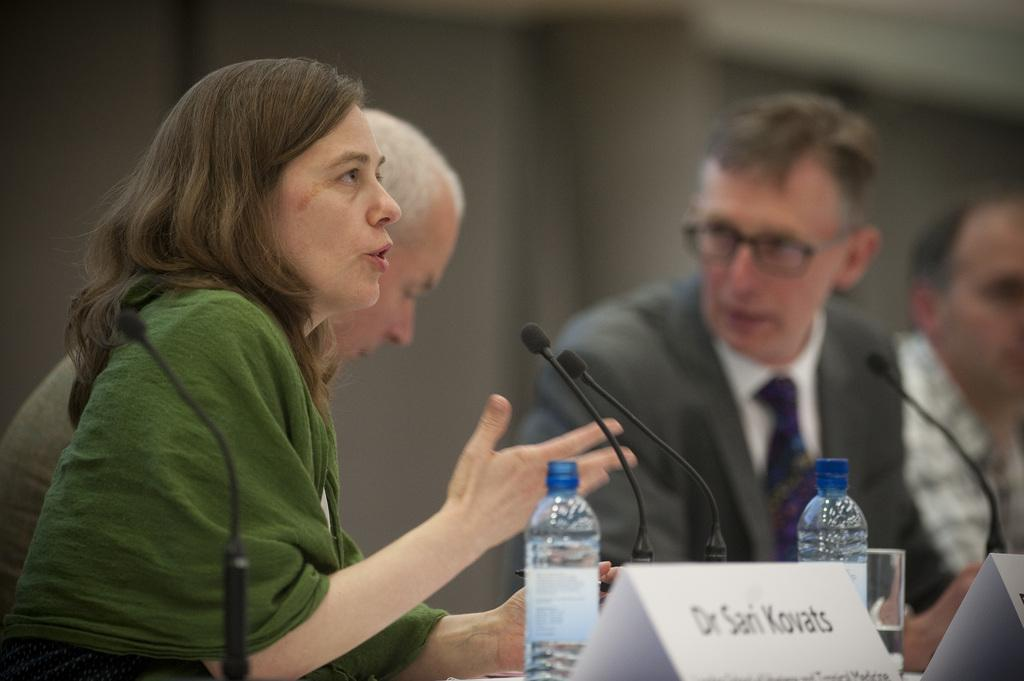How many individuals are present in the image? There are four people in the image. What objects are in front of the people? There are microphones, bottles, name boards, and a glass in front of the people. What might the people be using the microphones for? The microphones suggest that the people might be participating in a discussion or presentation. How can the people be identified in the image? The name boards in front of the people can be used to identify them. What is the condition of the background in the image? The background of the image is blurry. What type of marble is visible on the table in the image? There is no marble present in the image; the table does not have a marble surface. How many beans are on the table in the image? There are no beans visible in the image. 